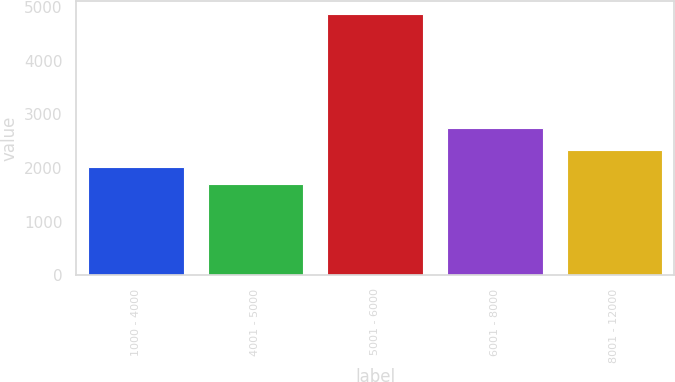Convert chart. <chart><loc_0><loc_0><loc_500><loc_500><bar_chart><fcel>1000 - 4000<fcel>4001 - 5000<fcel>5001 - 6000<fcel>6001 - 8000<fcel>8001 - 12000<nl><fcel>2023.9<fcel>1708<fcel>4867<fcel>2753<fcel>2339.8<nl></chart> 